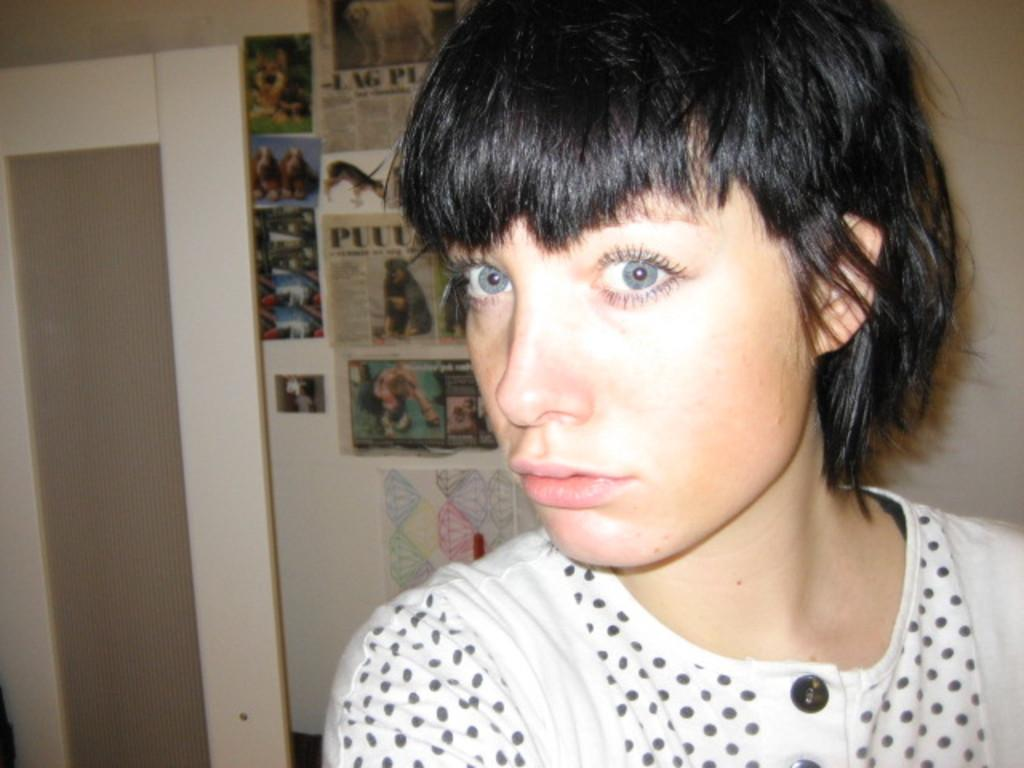Who or what is present in the image? There is a person in the image. What can be seen in the foreground of the image? There is a door in the image. What is visible in the background of the image? There are posters on the wall in the background of the image. What hobbies does the tiger have, as seen in the image? There is no tiger present in the image, so it is not possible to determine its hobbies. 